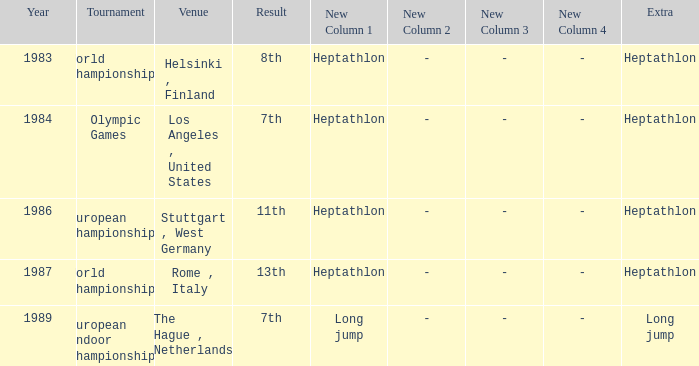Where was the 1984 Olympics hosted? Olympic Games. Give me the full table as a dictionary. {'header': ['Year', 'Tournament', 'Venue', 'Result', 'New Column 1', 'New Column 2', 'New Column 3', 'New Column 4', 'Extra'], 'rows': [['1983', 'World Championships', 'Helsinki , Finland', '8th', 'Heptathlon', '-', '-', '-', 'Heptathlon'], ['1984', 'Olympic Games', 'Los Angeles , United States', '7th', 'Heptathlon', '-', '-', '-', 'Heptathlon'], ['1986', 'European Championships', 'Stuttgart , West Germany', '11th', 'Heptathlon', '-', '-', '-', 'Heptathlon'], ['1987', 'World Championships', 'Rome , Italy', '13th', 'Heptathlon', '-', '-', '-', 'Heptathlon'], ['1989', 'European Indoor Championships', 'The Hague , Netherlands', '7th', 'Long jump', '-', '-', '-', 'Long jump']]} 